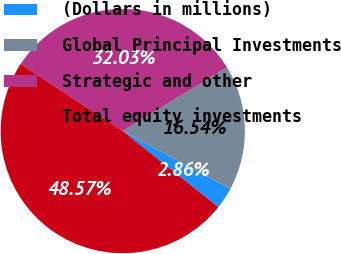Convert chart. <chart><loc_0><loc_0><loc_500><loc_500><pie_chart><fcel>(Dollars in millions)<fcel>Global Principal Investments<fcel>Strategic and other<fcel>Total equity investments<nl><fcel>2.86%<fcel>16.54%<fcel>32.03%<fcel>48.57%<nl></chart> 